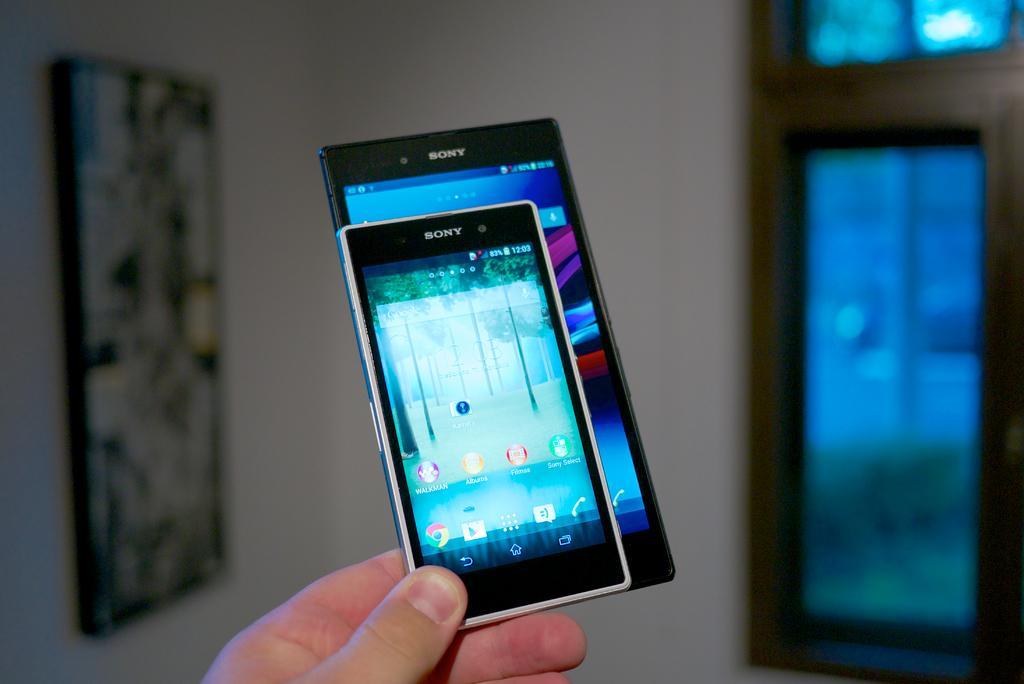<image>
Write a terse but informative summary of the picture. A person holding two Sony brand phones in one hand 